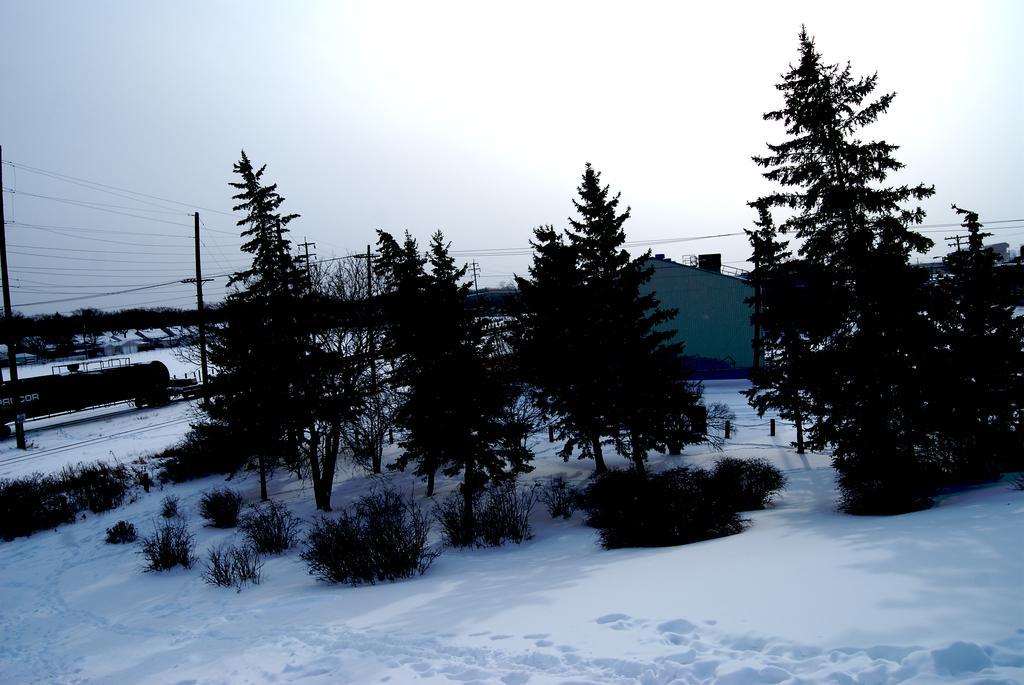How would you summarize this image in a sentence or two? In this image we can see trees, plants and snow. In the background we can see a house, poles, wires, trees, cylindrical object on the left side and clouds in the sky. 